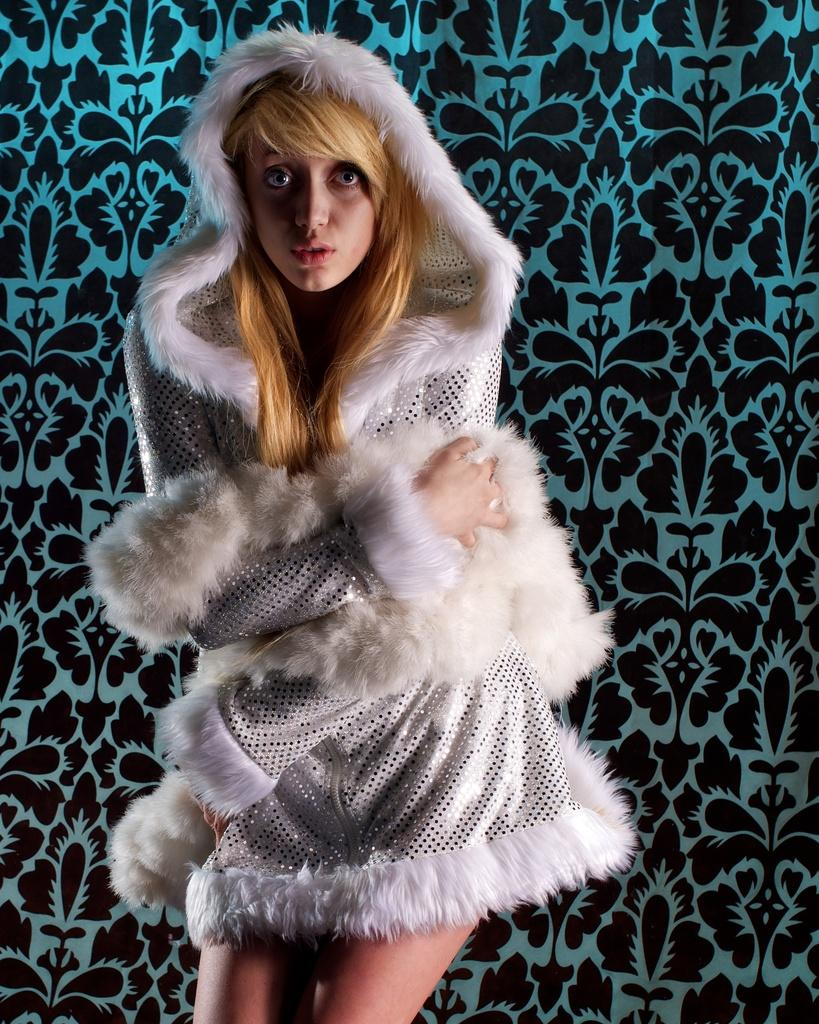Who is present in the image? There is a woman in the image. What is the woman wearing? The woman is wearing a white and black colored dress. How is the woman described? The woman is described as stunning. What colors are present in the background of the image? The background of the image is blue and black colored. How many pigs are visible in the image? There are no pigs present in the image. What type of hat is the woman wearing in the image? The woman is not wearing a hat in the image. 